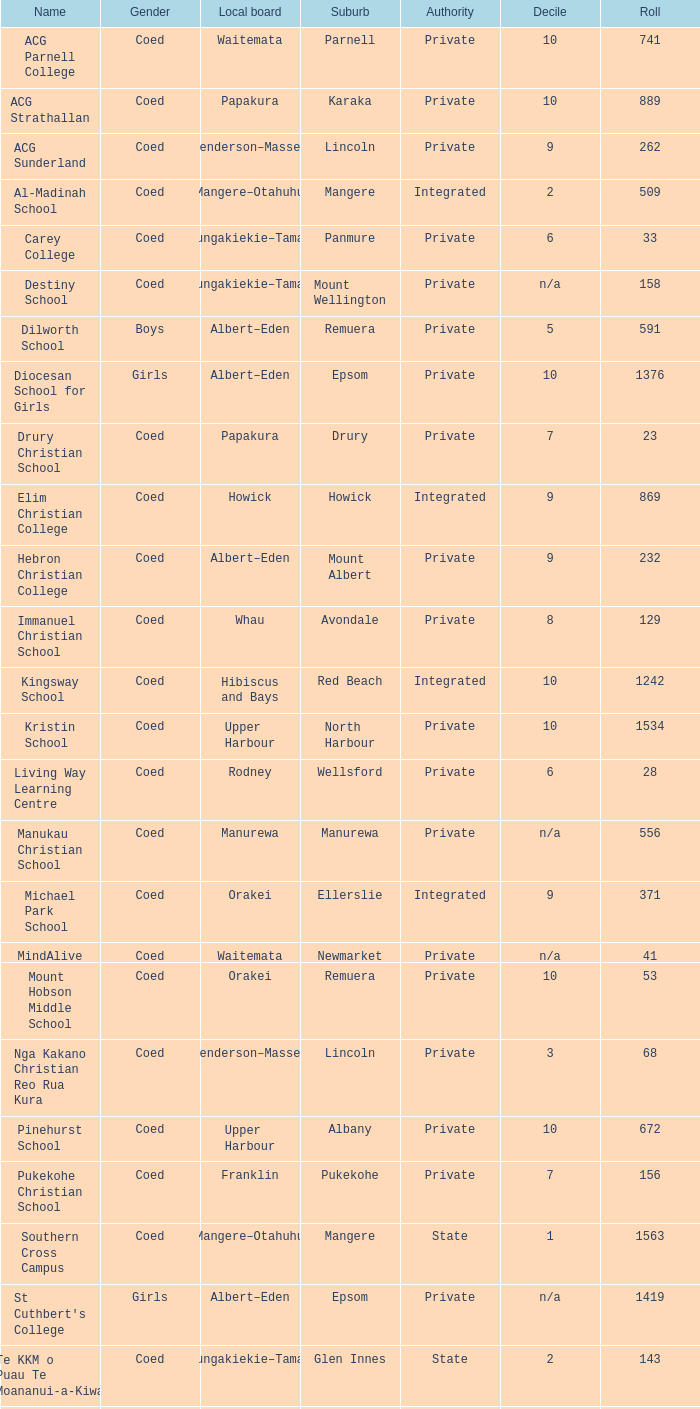What is the name when the local board is albert–eden, and a Decile of 9? Hebron Christian College. 